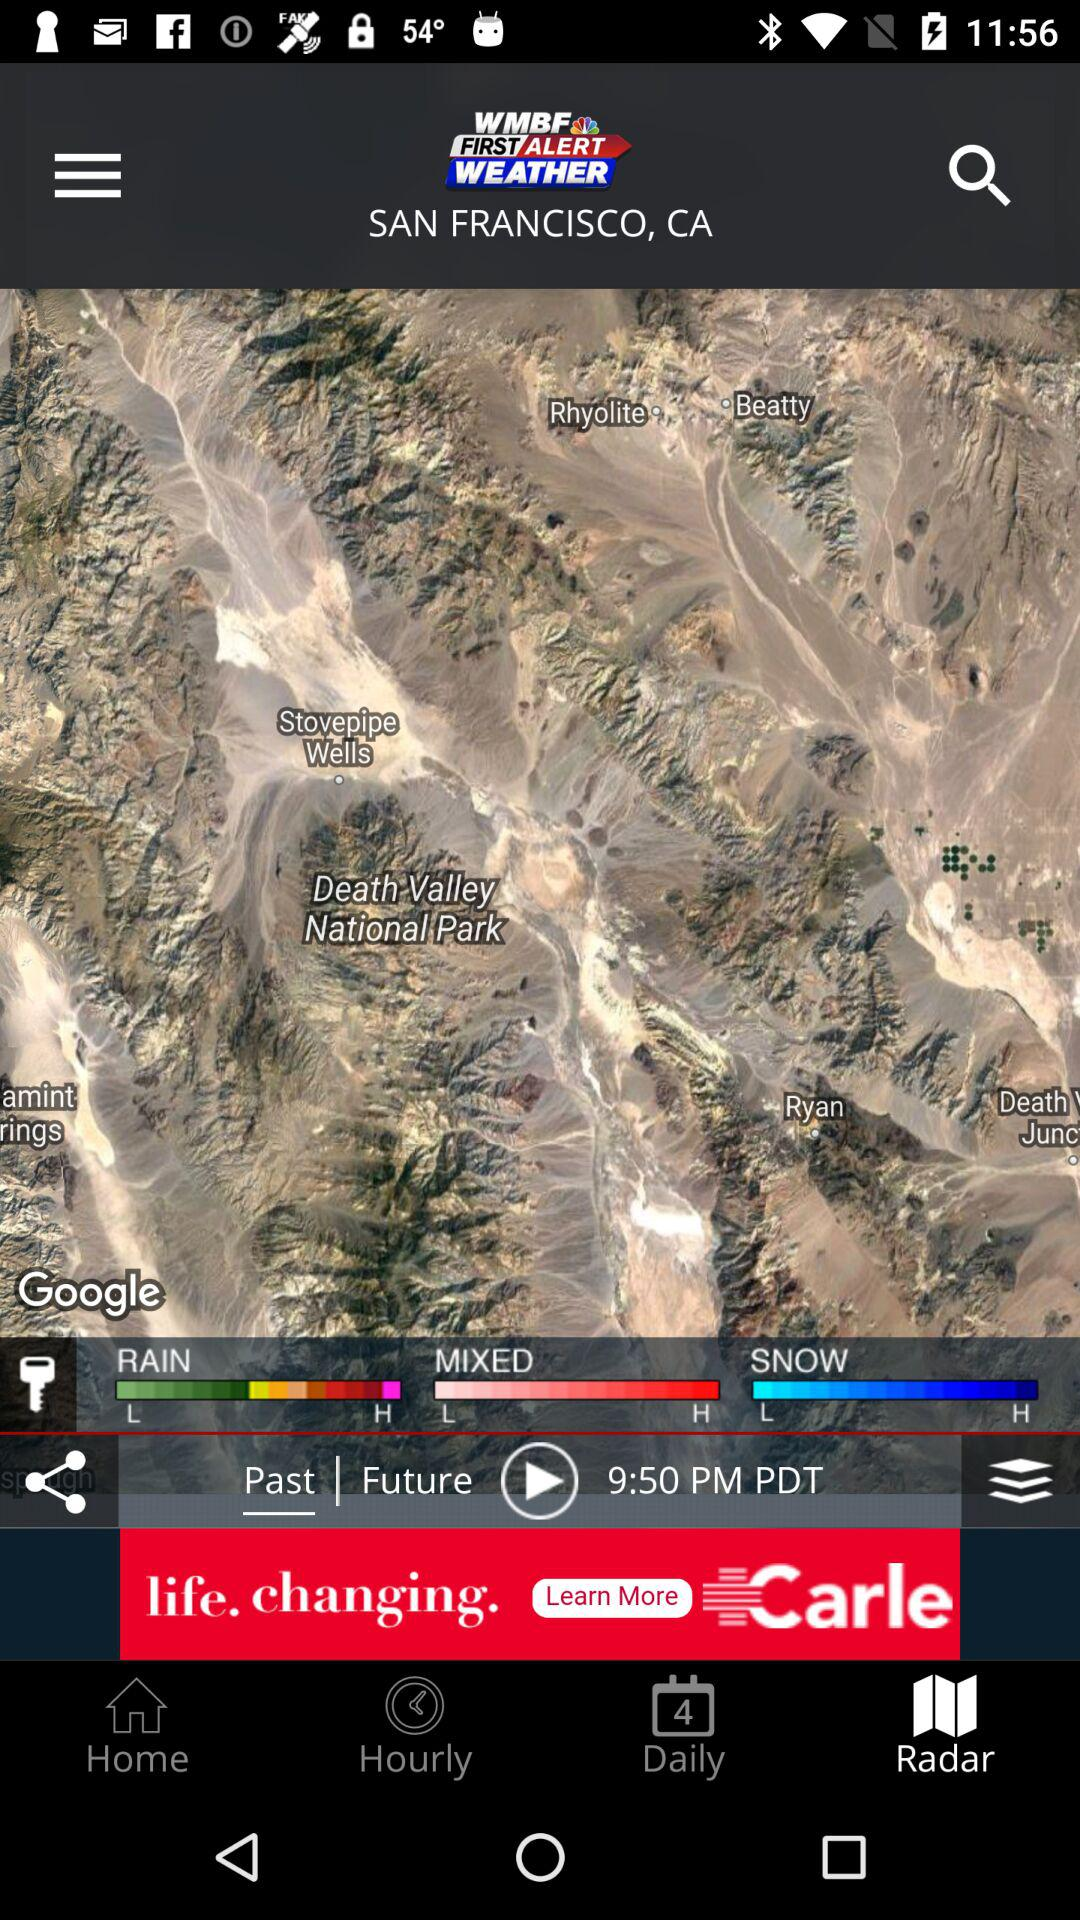How many types of weather conditions are shown?
Answer the question using a single word or phrase. 3 